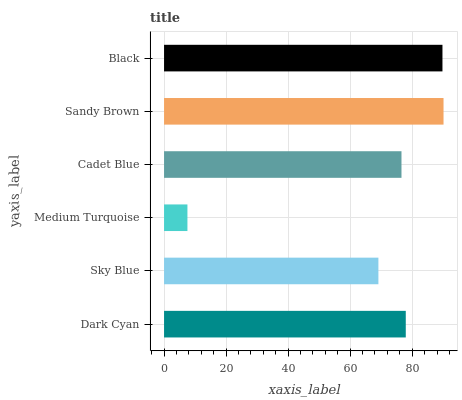Is Medium Turquoise the minimum?
Answer yes or no. Yes. Is Sandy Brown the maximum?
Answer yes or no. Yes. Is Sky Blue the minimum?
Answer yes or no. No. Is Sky Blue the maximum?
Answer yes or no. No. Is Dark Cyan greater than Sky Blue?
Answer yes or no. Yes. Is Sky Blue less than Dark Cyan?
Answer yes or no. Yes. Is Sky Blue greater than Dark Cyan?
Answer yes or no. No. Is Dark Cyan less than Sky Blue?
Answer yes or no. No. Is Dark Cyan the high median?
Answer yes or no. Yes. Is Cadet Blue the low median?
Answer yes or no. Yes. Is Black the high median?
Answer yes or no. No. Is Sandy Brown the low median?
Answer yes or no. No. 